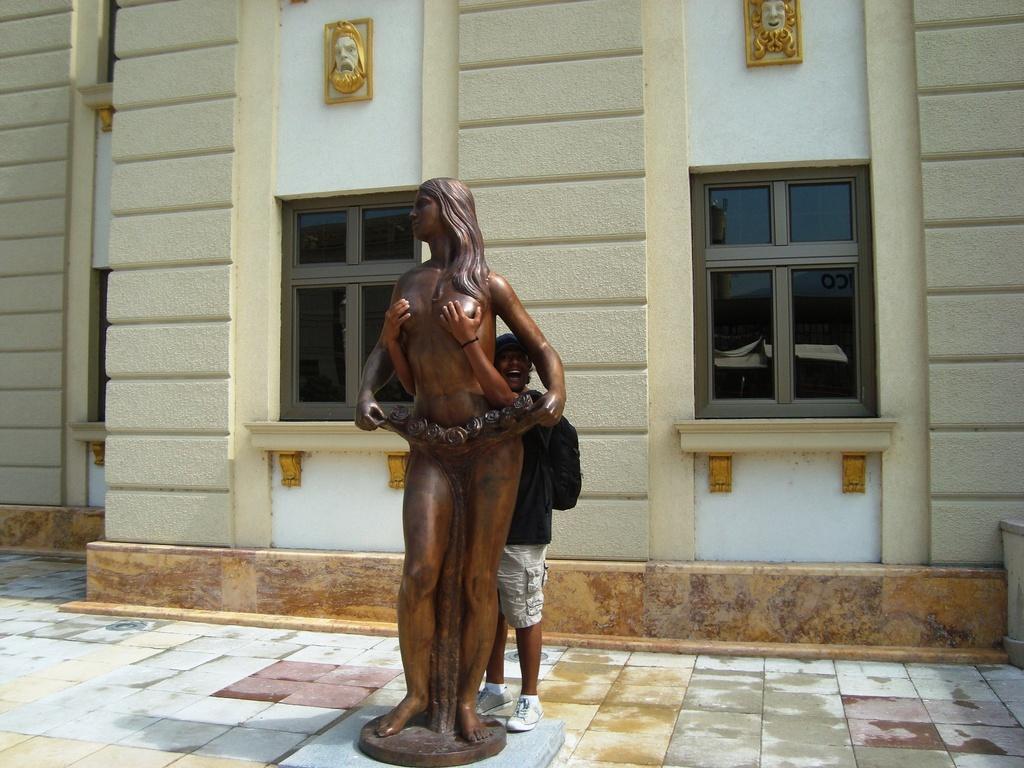In one or two sentences, can you explain what this image depicts? In this image we can see a bronze sculpture. Behind the sculpture, we can see a person and a wall of a building on which there are few windows and designs. 